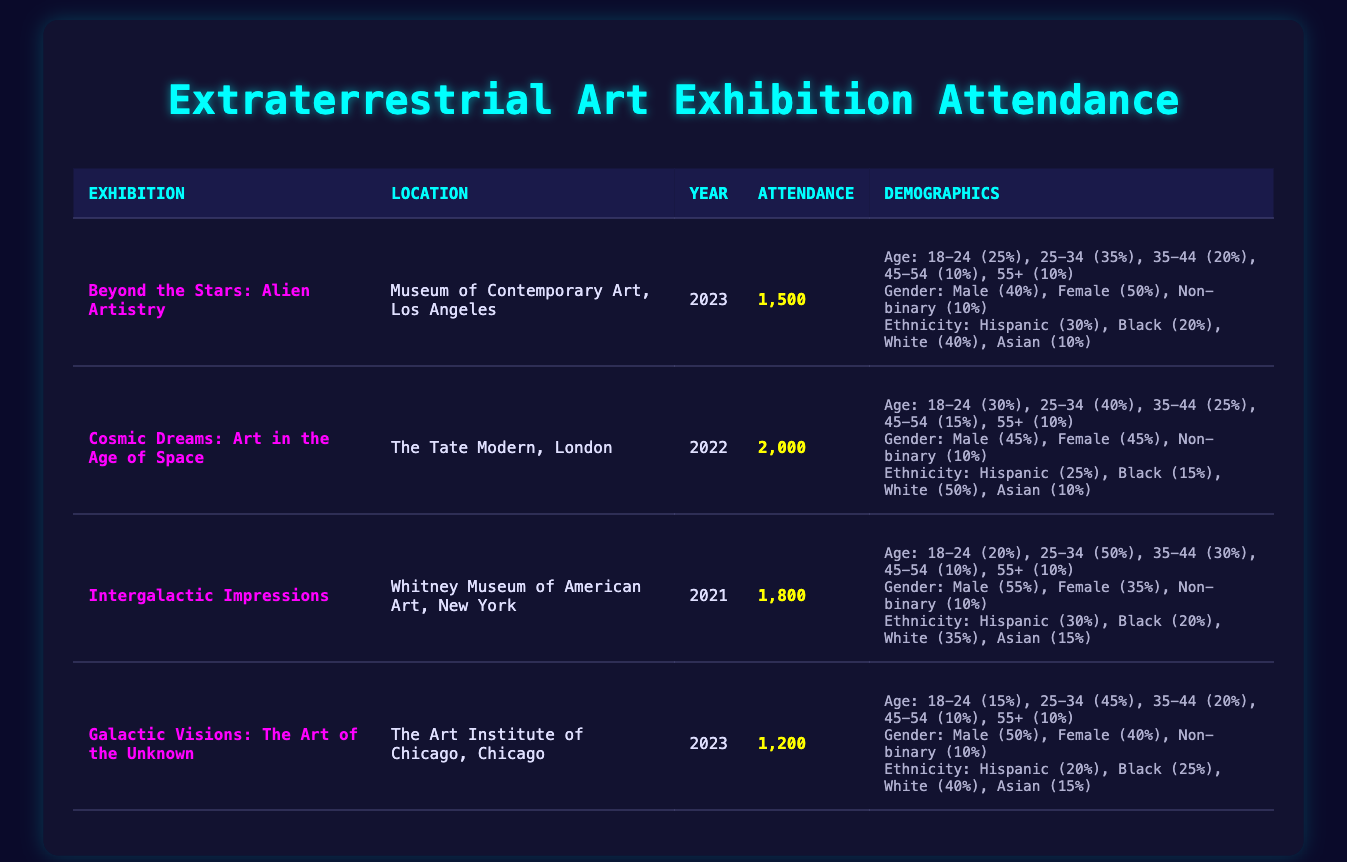What was the total attendance for the exhibitions in 2023? The total attendance for the exhibitions in 2023 can be calculated by adding the attendance of "Beyond the Stars: Alien Artistry" (1500) and "Galactic Visions: The Art of the Unknown" (1200). Therefore, the total is 1500 + 1200 = 2700.
Answer: 2700 What percentage of attendees were aged 25-34 at the "Cosmic Dreams" exhibition? At "Cosmic Dreams: Art in the Age of Space," the attendance was 2000, and 40% of attendees were aged 25-34. To find the number of attendees in this age group, calculate 40% of 2000, which is 0.40 * 2000 = 800.
Answer: 800 Did the "Intergalactic Impressions" exhibition attract more male or female attendees? For "Intergalactic Impressions," there were 55 males and 35 females. Since 55 is greater than 35, more male attendees were present at the exhibition.
Answer: Yes What was the average attendance across all exhibitions listed? The total attendance across all exhibitions is 1500 + 2000 + 1800 + 1200 = 6500. Since there are 4 exhibitions, the average attendance is 6500 / 4 = 1625.
Answer: 1625 Which exhibition had the highest percentage of Hispanic attendees, and what was that percentage? The exhibition with the highest percentage of Hispanic attendees is "Beyond the Stars: Alien Artistry" with 30%.
Answer: Beyond the Stars: Alien Artistry, 30% Was the gender distribution equal in the "Galactic Visions: The Art of the Unknown" exhibition? In "Galactic Visions: The Art of the Unknown," the gender breakdown was 50 males, 40 females, and 10 non-binary. Thus, it was not equal, as males and females do not match in numbers.
Answer: No Which age group had the lowest number of attendees across all exhibitions? The lowest number of attendees in any age group is from the 55+ category in all exhibitions. The counts are: 10 (Beyond the Stars), 10 (Cosmic Dreams), 10 (Intergalactic Impressions), and 10 (Galactic Visions), making it consistently 10 across all, suggesting equal low attendance across exhibitions.
Answer: 55+, 10 What is the difference in attendance between the "Cosmic Dreams" and "Galactic Visions" exhibitions? The attendance for "Cosmic Dreams" is 2000, and for "Galactic Visions," it is 1200. The difference is calculated by subtracting: 2000 - 1200 = 800.
Answer: 800 Which exhibition had the highest total attendance? By comparing the attendance numbers from each exhibition, we see that "Cosmic Dreams: Art in the Age of Space" had the highest attendance at 2000.
Answer: Cosmic Dreams, 2000 